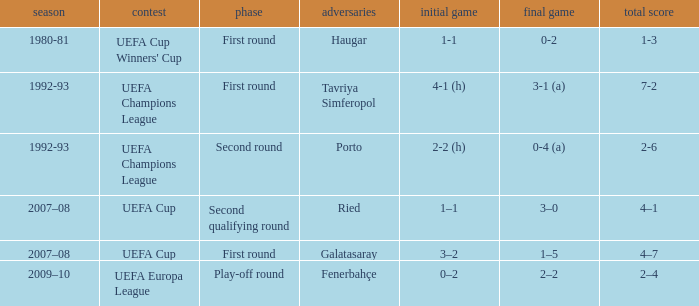 what's the aggregate where 1st leg is 3–2 4–7. 